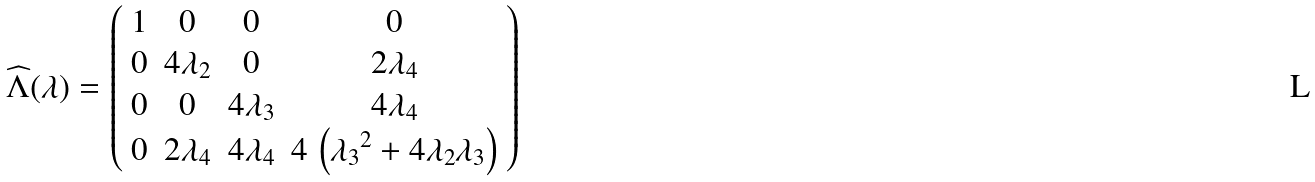Convert formula to latex. <formula><loc_0><loc_0><loc_500><loc_500>\widehat { \Lambda } ( \lambda ) = \left ( \begin{array} { c c c c } 1 & 0 & 0 & 0 \\ 0 & 4 \lambda _ { 2 } & 0 & 2 \lambda _ { 4 } \\ 0 & 0 & 4 \lambda _ { 3 } & 4 \lambda _ { 4 } \\ 0 & 2 \lambda _ { 4 } & 4 \lambda _ { 4 } & 4 \, \left ( { \lambda _ { 3 } } ^ { 2 } + 4 \lambda _ { 2 } \lambda _ { 3 } \right ) \end{array} \right )</formula> 